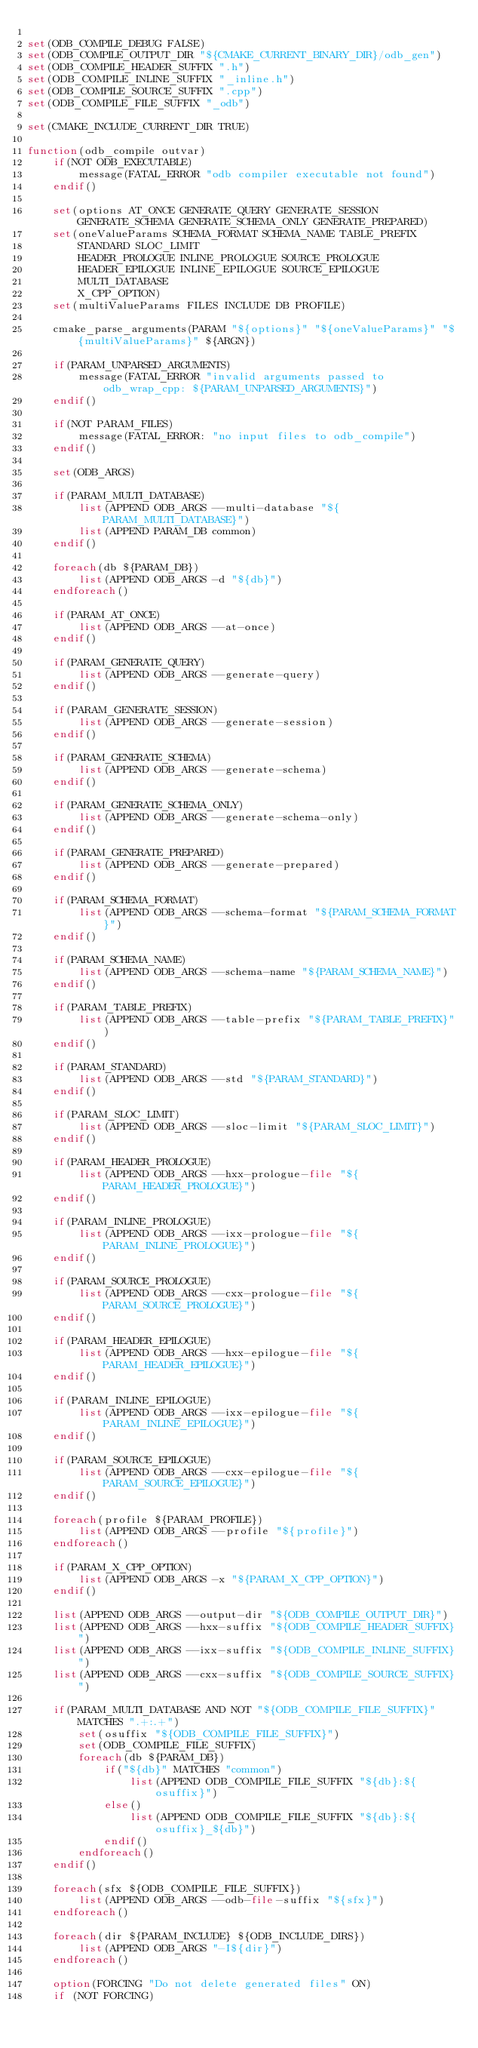<code> <loc_0><loc_0><loc_500><loc_500><_CMake_>
set(ODB_COMPILE_DEBUG FALSE)
set(ODB_COMPILE_OUTPUT_DIR "${CMAKE_CURRENT_BINARY_DIR}/odb_gen")
set(ODB_COMPILE_HEADER_SUFFIX ".h")
set(ODB_COMPILE_INLINE_SUFFIX "_inline.h")
set(ODB_COMPILE_SOURCE_SUFFIX ".cpp")
set(ODB_COMPILE_FILE_SUFFIX "_odb")

set(CMAKE_INCLUDE_CURRENT_DIR TRUE)

function(odb_compile outvar)
	if(NOT ODB_EXECUTABLE)
		message(FATAL_ERROR "odb compiler executable not found")
	endif()

	set(options AT_ONCE GENERATE_QUERY GENERATE_SESSION GENERATE_SCHEMA GENERATE_SCHEMA_ONLY GENERATE_PREPARED)
	set(oneValueParams SCHEMA_FORMAT SCHEMA_NAME TABLE_PREFIX
		STANDARD SLOC_LIMIT
		HEADER_PROLOGUE INLINE_PROLOGUE SOURCE_PROLOGUE
		HEADER_EPILOGUE INLINE_EPILOGUE SOURCE_EPILOGUE
		MULTI_DATABASE
		X_CPP_OPTION)
	set(multiValueParams FILES INCLUDE DB PROFILE)

	cmake_parse_arguments(PARAM "${options}" "${oneValueParams}" "${multiValueParams}" ${ARGN})

	if(PARAM_UNPARSED_ARGUMENTS)
		message(FATAL_ERROR "invalid arguments passed to odb_wrap_cpp: ${PARAM_UNPARSED_ARGUMENTS}")
	endif()

	if(NOT PARAM_FILES)
		message(FATAL_ERROR: "no input files to odb_compile")
	endif()

	set(ODB_ARGS)

	if(PARAM_MULTI_DATABASE)
		list(APPEND ODB_ARGS --multi-database "${PARAM_MULTI_DATABASE}")
		list(APPEND PARAM_DB common)
	endif()

	foreach(db ${PARAM_DB})
		list(APPEND ODB_ARGS -d "${db}")
	endforeach()

	if(PARAM_AT_ONCE)
		list(APPEND ODB_ARGS --at-once)
	endif()

	if(PARAM_GENERATE_QUERY)
		list(APPEND ODB_ARGS --generate-query)
	endif()

	if(PARAM_GENERATE_SESSION)
		list(APPEND ODB_ARGS --generate-session)
	endif()

	if(PARAM_GENERATE_SCHEMA)
		list(APPEND ODB_ARGS --generate-schema)
	endif()

	if(PARAM_GENERATE_SCHEMA_ONLY)
		list(APPEND ODB_ARGS --generate-schema-only)
	endif()

	if(PARAM_GENERATE_PREPARED)
		list(APPEND ODB_ARGS --generate-prepared)
	endif()

	if(PARAM_SCHEMA_FORMAT)
		list(APPEND ODB_ARGS --schema-format "${PARAM_SCHEMA_FORMAT}")
	endif()

	if(PARAM_SCHEMA_NAME)
		list(APPEND ODB_ARGS --schema-name "${PARAM_SCHEMA_NAME}")
	endif()

	if(PARAM_TABLE_PREFIX)
		list(APPEND ODB_ARGS --table-prefix "${PARAM_TABLE_PREFIX}")
	endif()

	if(PARAM_STANDARD)
		list(APPEND ODB_ARGS --std "${PARAM_STANDARD}")
	endif()

	if(PARAM_SLOC_LIMIT)
		list(APPEND ODB_ARGS --sloc-limit "${PARAM_SLOC_LIMIT}")
	endif()

	if(PARAM_HEADER_PROLOGUE)
		list(APPEND ODB_ARGS --hxx-prologue-file "${PARAM_HEADER_PROLOGUE}")
	endif()

	if(PARAM_INLINE_PROLOGUE)
		list(APPEND ODB_ARGS --ixx-prologue-file "${PARAM_INLINE_PROLOGUE}")
	endif()

	if(PARAM_SOURCE_PROLOGUE)
		list(APPEND ODB_ARGS --cxx-prologue-file "${PARAM_SOURCE_PROLOGUE}")
	endif()

	if(PARAM_HEADER_EPILOGUE)
		list(APPEND ODB_ARGS --hxx-epilogue-file "${PARAM_HEADER_EPILOGUE}")
	endif()

	if(PARAM_INLINE_EPILOGUE)
		list(APPEND ODB_ARGS --ixx-epilogue-file "${PARAM_INLINE_EPILOGUE}")
	endif()

	if(PARAM_SOURCE_EPILOGUE)
		list(APPEND ODB_ARGS --cxx-epilogue-file "${PARAM_SOURCE_EPILOGUE}")
	endif()

	foreach(profile ${PARAM_PROFILE})
		list(APPEND ODB_ARGS --profile "${profile}")
	endforeach()

	if(PARAM_X_CPP_OPTION)
		list(APPEND ODB_ARGS -x "${PARAM_X_CPP_OPTION}")
	endif()

	list(APPEND ODB_ARGS --output-dir "${ODB_COMPILE_OUTPUT_DIR}")
	list(APPEND ODB_ARGS --hxx-suffix "${ODB_COMPILE_HEADER_SUFFIX}")
	list(APPEND ODB_ARGS --ixx-suffix "${ODB_COMPILE_INLINE_SUFFIX}")
	list(APPEND ODB_ARGS --cxx-suffix "${ODB_COMPILE_SOURCE_SUFFIX}")

	if(PARAM_MULTI_DATABASE AND NOT "${ODB_COMPILE_FILE_SUFFIX}" MATCHES ".+:.+")
		set(osuffix "${ODB_COMPILE_FILE_SUFFIX}")
		set(ODB_COMPILE_FILE_SUFFIX)
		foreach(db ${PARAM_DB})
			if("${db}" MATCHES "common")
				list(APPEND ODB_COMPILE_FILE_SUFFIX "${db}:${osuffix}")
			else()
				list(APPEND ODB_COMPILE_FILE_SUFFIX "${db}:${osuffix}_${db}")
			endif()
		endforeach()
	endif()

	foreach(sfx ${ODB_COMPILE_FILE_SUFFIX})
		list(APPEND ODB_ARGS --odb-file-suffix "${sfx}")
	endforeach()

	foreach(dir ${PARAM_INCLUDE} ${ODB_INCLUDE_DIRS})
		list(APPEND ODB_ARGS "-I${dir}")
	endforeach()

	option(FORCING "Do not delete generated files" ON)
	if (NOT FORCING)</code> 